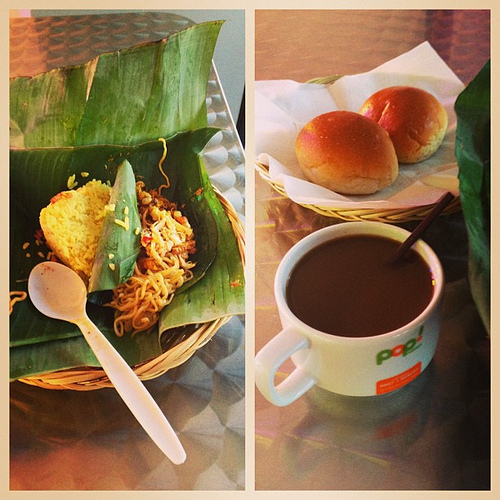What piece of furniture is silver? The sleek surface beneath the meal sports a metallic silver finish, giving the table an urban, contemporary vibe. 